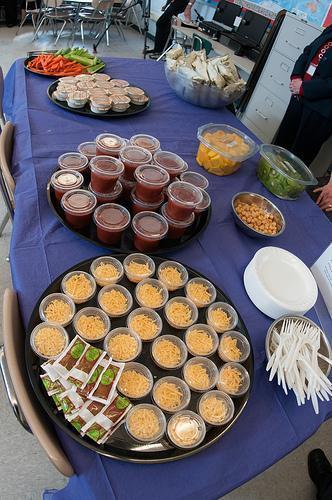How many chairs are on the left side of the purple table?
Give a very brief answer. 3. 